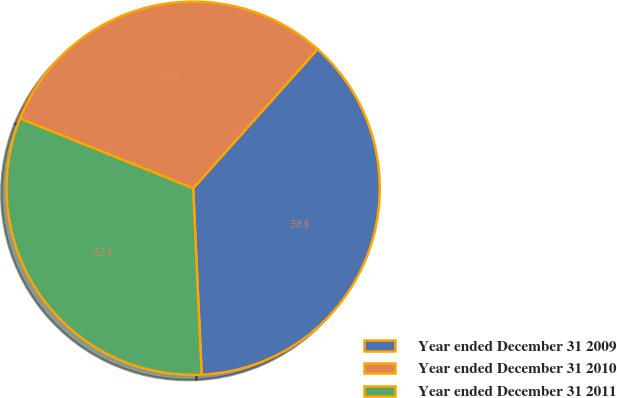<chart> <loc_0><loc_0><loc_500><loc_500><pie_chart><fcel>Year ended December 31 2009<fcel>Year ended December 31 2010<fcel>Year ended December 31 2011<nl><fcel>37.66%<fcel>30.52%<fcel>31.82%<nl></chart> 